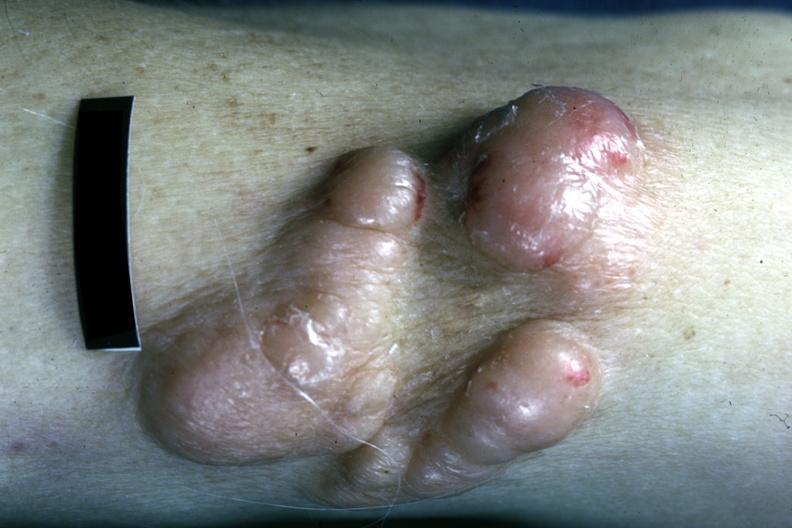what is present?
Answer the question using a single word or phrase. Multiple myeloma 